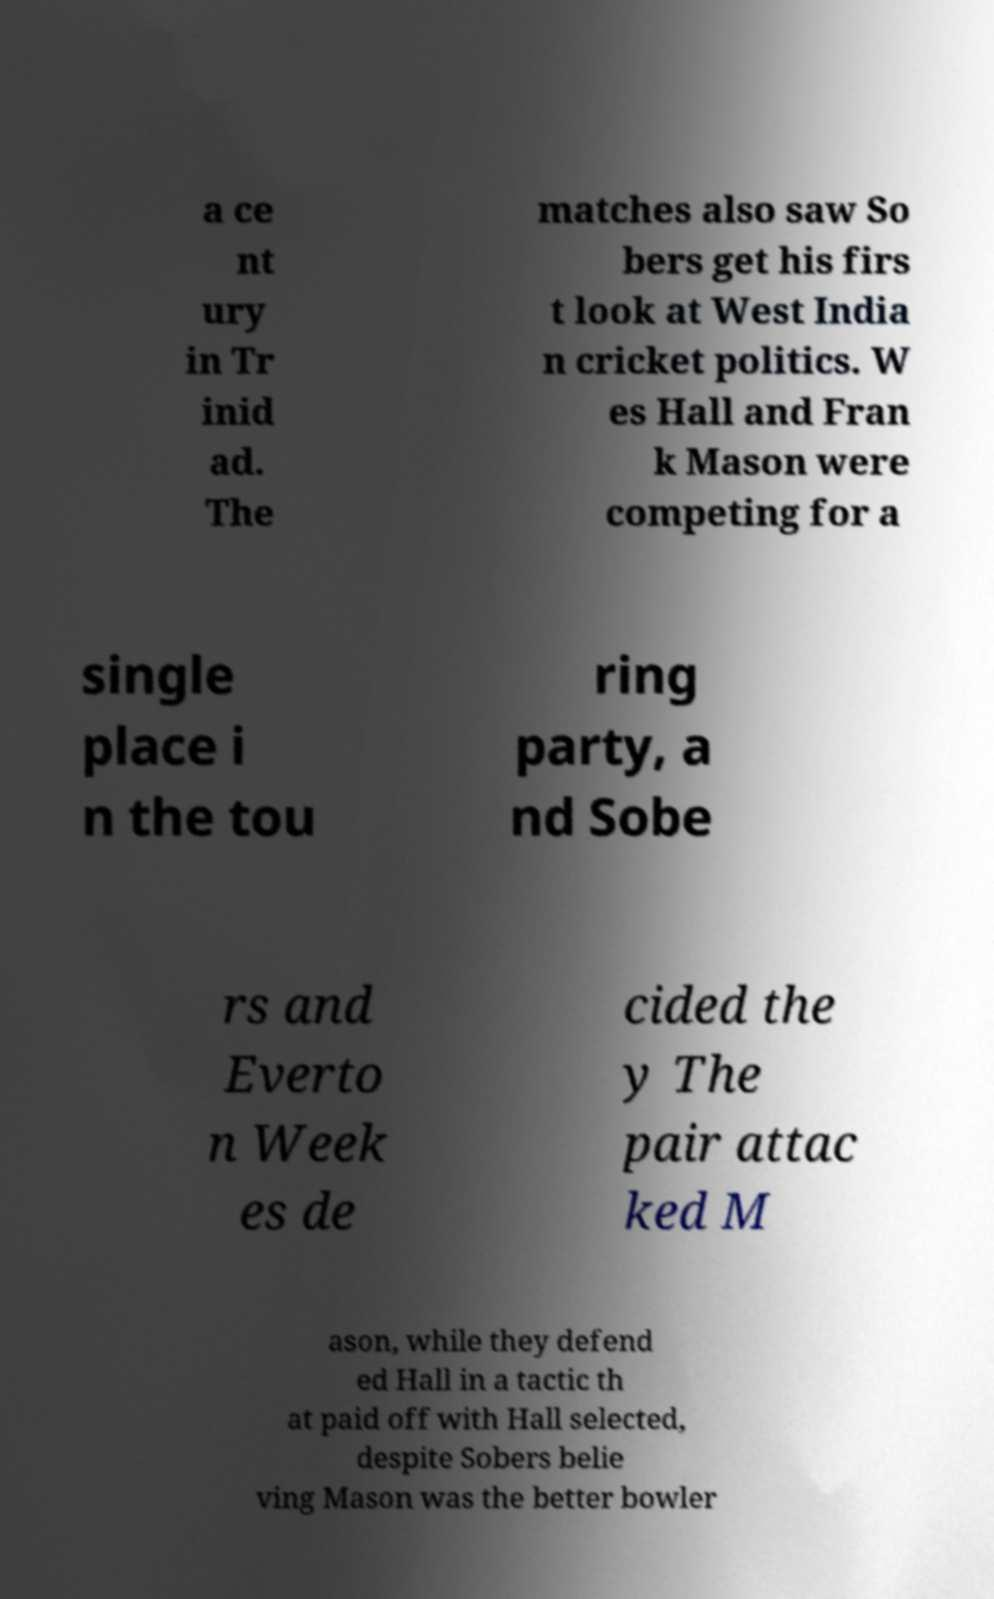Can you read and provide the text displayed in the image?This photo seems to have some interesting text. Can you extract and type it out for me? a ce nt ury in Tr inid ad. The matches also saw So bers get his firs t look at West India n cricket politics. W es Hall and Fran k Mason were competing for a single place i n the tou ring party, a nd Sobe rs and Everto n Week es de cided the y The pair attac ked M ason, while they defend ed Hall in a tactic th at paid off with Hall selected, despite Sobers belie ving Mason was the better bowler 